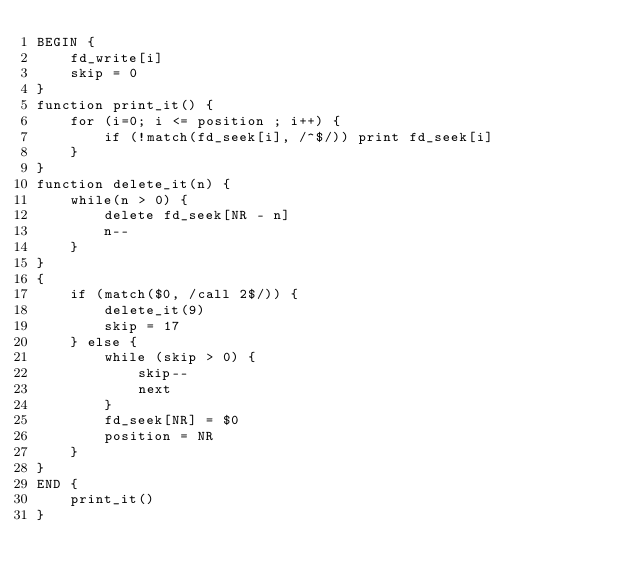Convert code to text. <code><loc_0><loc_0><loc_500><loc_500><_Awk_>BEGIN {
    fd_write[i]
    skip = 0
}
function print_it() {
    for (i=0; i <= position ; i++) {
        if (!match(fd_seek[i], /^$/)) print fd_seek[i]
    }
}
function delete_it(n) {
    while(n > 0) {
        delete fd_seek[NR - n]
        n--
    }
}
{
    if (match($0, /call 2$/)) {
        delete_it(9)
        skip = 17
    } else {
        while (skip > 0) {
            skip--
            next
        }
        fd_seek[NR] = $0
        position = NR
    }
}
END {
    print_it()
}</code> 